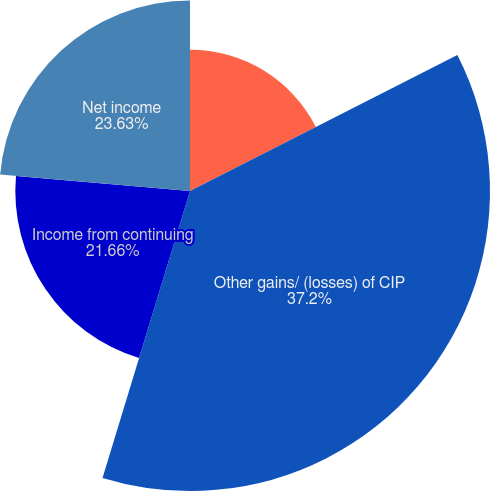Convert chart. <chart><loc_0><loc_0><loc_500><loc_500><pie_chart><fcel>Total operating expenses<fcel>Other gains/ (losses) of CIP<fcel>Income from continuing<fcel>Net income<nl><fcel>17.51%<fcel>37.2%<fcel>21.66%<fcel>23.63%<nl></chart> 